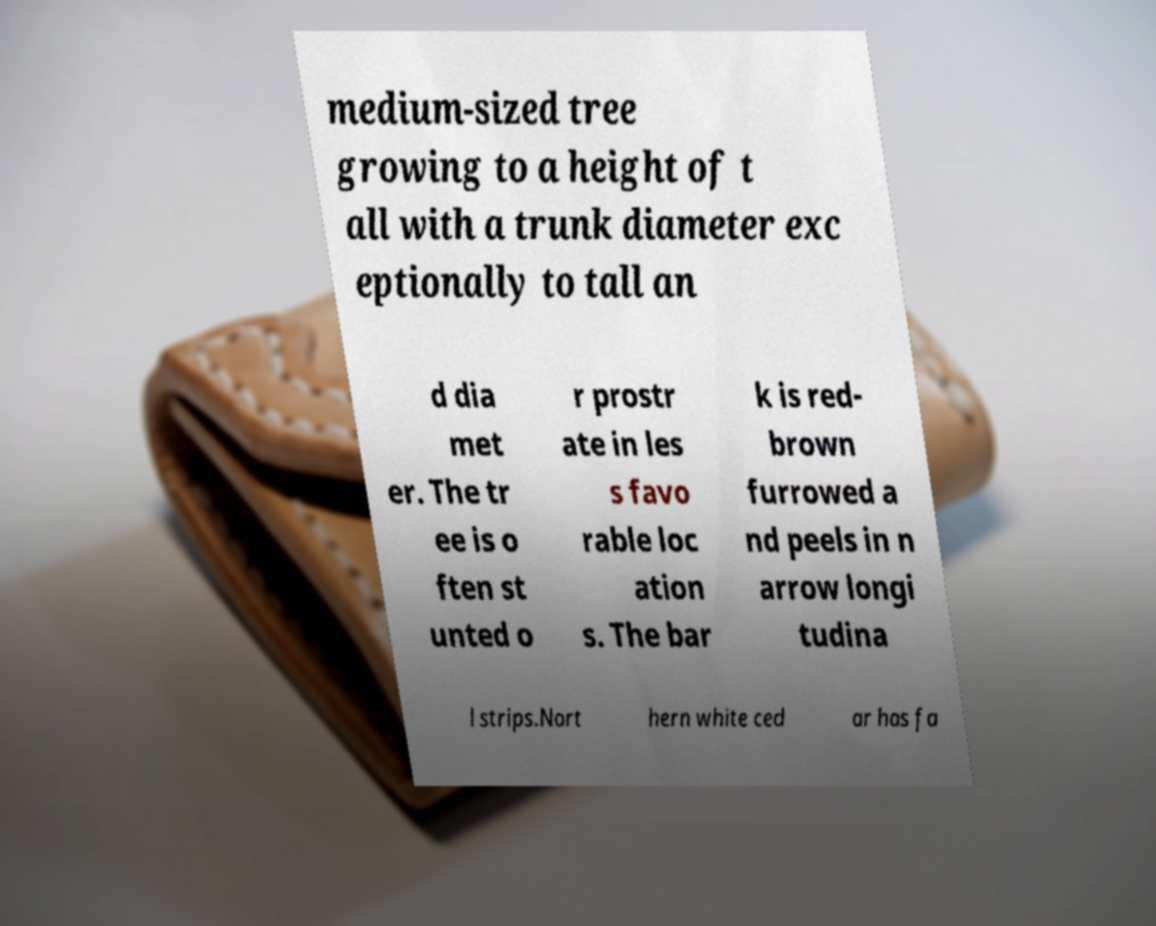Could you assist in decoding the text presented in this image and type it out clearly? medium-sized tree growing to a height of t all with a trunk diameter exc eptionally to tall an d dia met er. The tr ee is o ften st unted o r prostr ate in les s favo rable loc ation s. The bar k is red- brown furrowed a nd peels in n arrow longi tudina l strips.Nort hern white ced ar has fa 